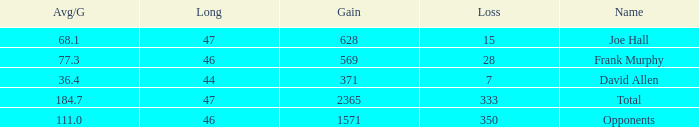How much Loss has a Gain smaller than 1571, and a Long smaller than 47, and an Avg/G of 36.4? 1.0. 